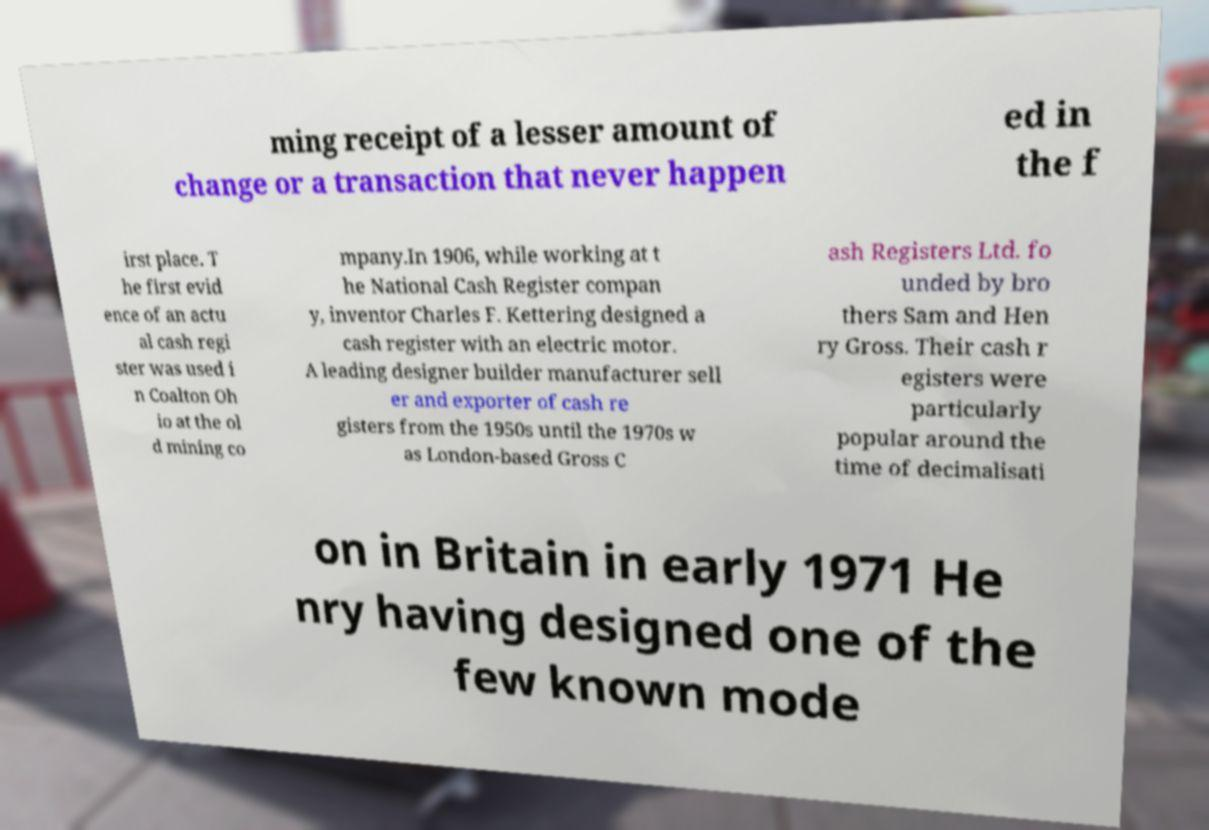Please identify and transcribe the text found in this image. ming receipt of a lesser amount of change or a transaction that never happen ed in the f irst place. T he first evid ence of an actu al cash regi ster was used i n Coalton Oh io at the ol d mining co mpany.In 1906, while working at t he National Cash Register compan y, inventor Charles F. Kettering designed a cash register with an electric motor. A leading designer builder manufacturer sell er and exporter of cash re gisters from the 1950s until the 1970s w as London-based Gross C ash Registers Ltd. fo unded by bro thers Sam and Hen ry Gross. Their cash r egisters were particularly popular around the time of decimalisati on in Britain in early 1971 He nry having designed one of the few known mode 